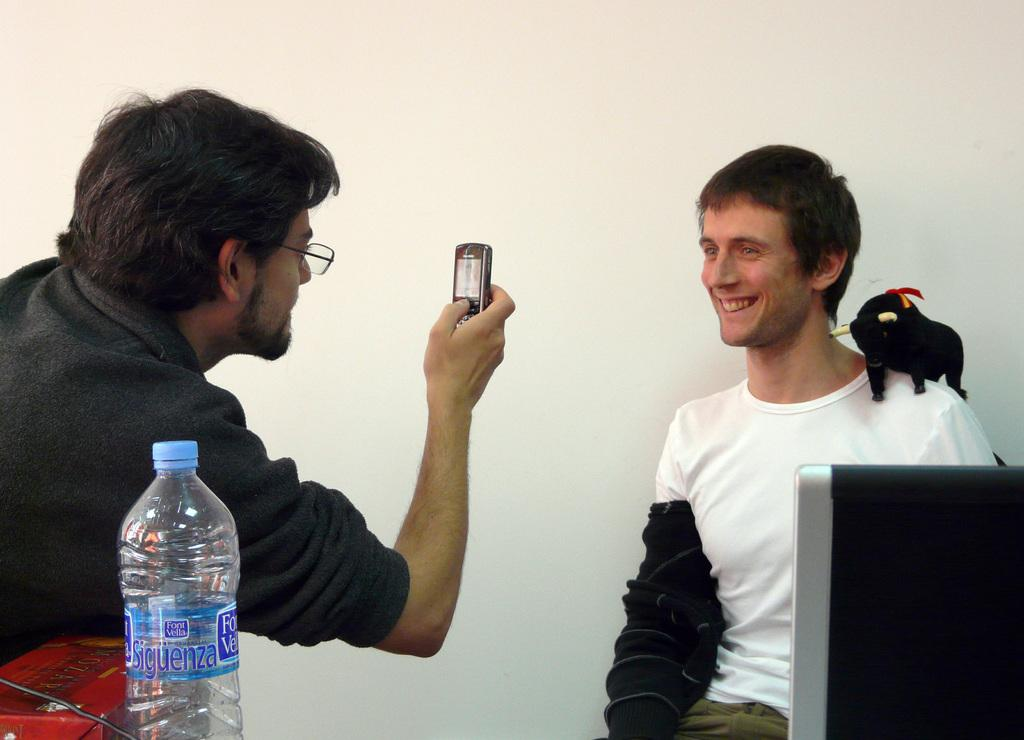What is the appearance of the man on the right side of the image? The man on the right is smiling and wearing a white t-shirt. What is the appearance of the man on the left side of the image? The man on the left is wearing a black t-shirt. What is the man on the left side of the image holding? The man on the left is holding a mobile. What type of lead is the man on the right using to hold the mobile? There is no mobile present in the image, and therefore no lead is being used. What type of knife or fork is the man on the left using to eat the ice cream? There is no ice cream or knife or fork present in the image. 